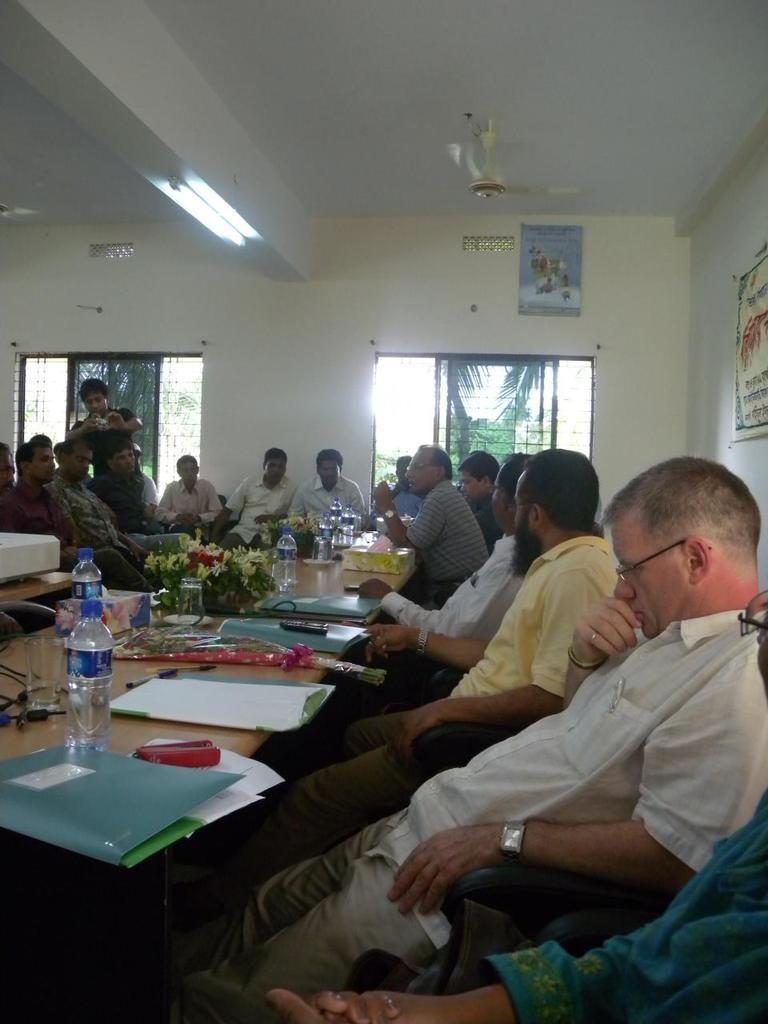What are the people in the image doing? The people in the image are sitting. What is in front of the people? There is a table in front of the people. What can be seen on the table? There are water bottles and files on the table. What language is being spoken by the people in the image? The provided facts do not mention any language being spoken, so it cannot be determined from the image. 